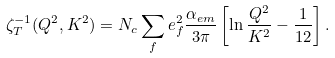Convert formula to latex. <formula><loc_0><loc_0><loc_500><loc_500>\zeta _ { T } ^ { - 1 } ( Q ^ { 2 } , K ^ { 2 } ) = N _ { c } \sum _ { f } e _ { f } ^ { 2 } { \frac { \alpha _ { e m } } { 3 \pi } } \left [ \ln { \frac { Q ^ { 2 } } { K ^ { 2 } } } - { \frac { 1 } { 1 2 } } \right ] .</formula> 